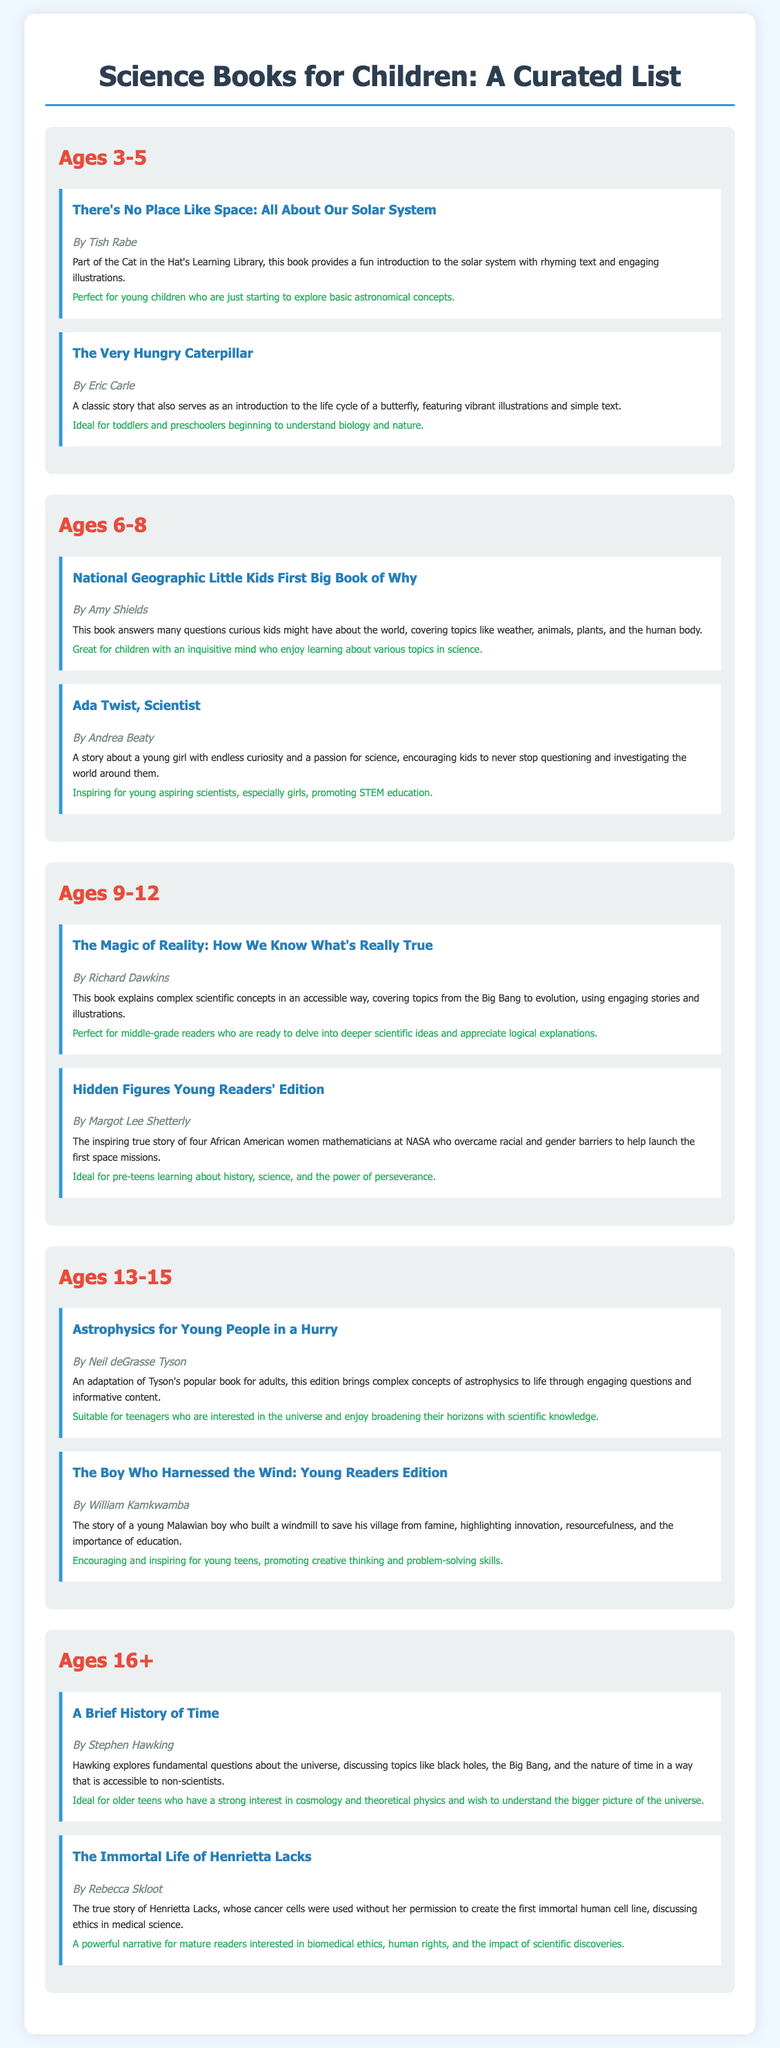What is the title of the book for ages 3-5 by Tish Rabe? The title is mentioned under the "Ages 3-5" section as "There's No Place Like Space: All About Our Solar System."
Answer: There's No Place Like Space: All About Our Solar System Who is the author of "The Very Hungry Caterpillar"? The author of this book is stated right next to the title in the "Ages 3-5" section.
Answer: Eric Carle Which book in the ages 9-12 section discusses the Big Bang? The summary of this book mentions that it explains complex scientific concepts including the Big Bang, found in the "Ages 9-12" section.
Answer: The Magic of Reality: How We Know What's Really True What age group is "Astrophysics for Young People in a Hurry" suitable for? The document specifies this book is in the "Ages 13-15" section, indicating its suitability for that age group.
Answer: Ages 13-15 How many books are listed for the age group of 16+? The document lists two books under the "Ages 16+" section.
Answer: 2 Which book encourages girls to pursue STEM education? This is highlighted in the suitability statement of "Ada Twist, Scientist" in the "Ages 6-8" section.
Answer: Ada Twist, Scientist What is the main theme of "Hidden Figures Young Readers' Edition"? The summary reveals that it tells the story of four African American women mathematicians at NASA, addressing themes of perseverance and barriers.
Answer: Perseverance and barriers in NASA What type of book is "A Brief History of Time"? The author discusses fundamental questions about the universe, making this a science book mentioned in the "Ages 16+" section.
Answer: Science book 